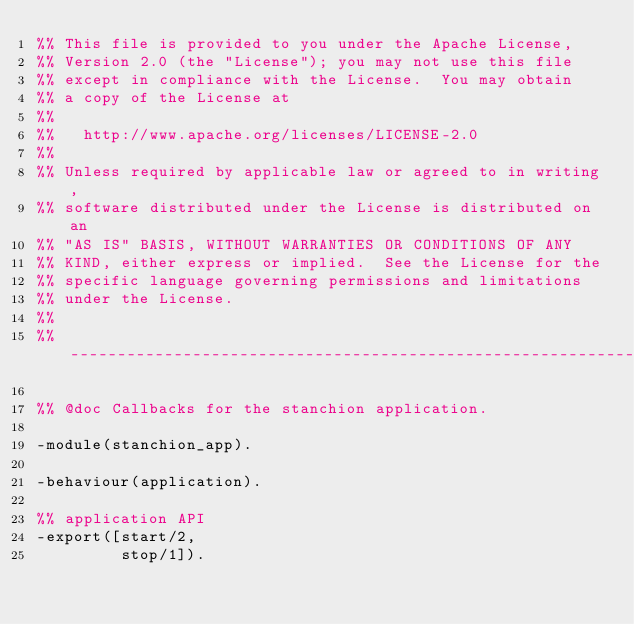<code> <loc_0><loc_0><loc_500><loc_500><_Erlang_>%% This file is provided to you under the Apache License,
%% Version 2.0 (the "License"); you may not use this file
%% except in compliance with the License.  You may obtain
%% a copy of the License at
%%
%%   http://www.apache.org/licenses/LICENSE-2.0
%%
%% Unless required by applicable law or agreed to in writing,
%% software distributed under the License is distributed on an
%% "AS IS" BASIS, WITHOUT WARRANTIES OR CONDITIONS OF ANY
%% KIND, either express or implied.  See the License for the
%% specific language governing permissions and limitations
%% under the License.
%%
%% ---------------------------------------------------------------------

%% @doc Callbacks for the stanchion application.

-module(stanchion_app).

-behaviour(application).

%% application API
-export([start/2,
         stop/1]).

</code> 